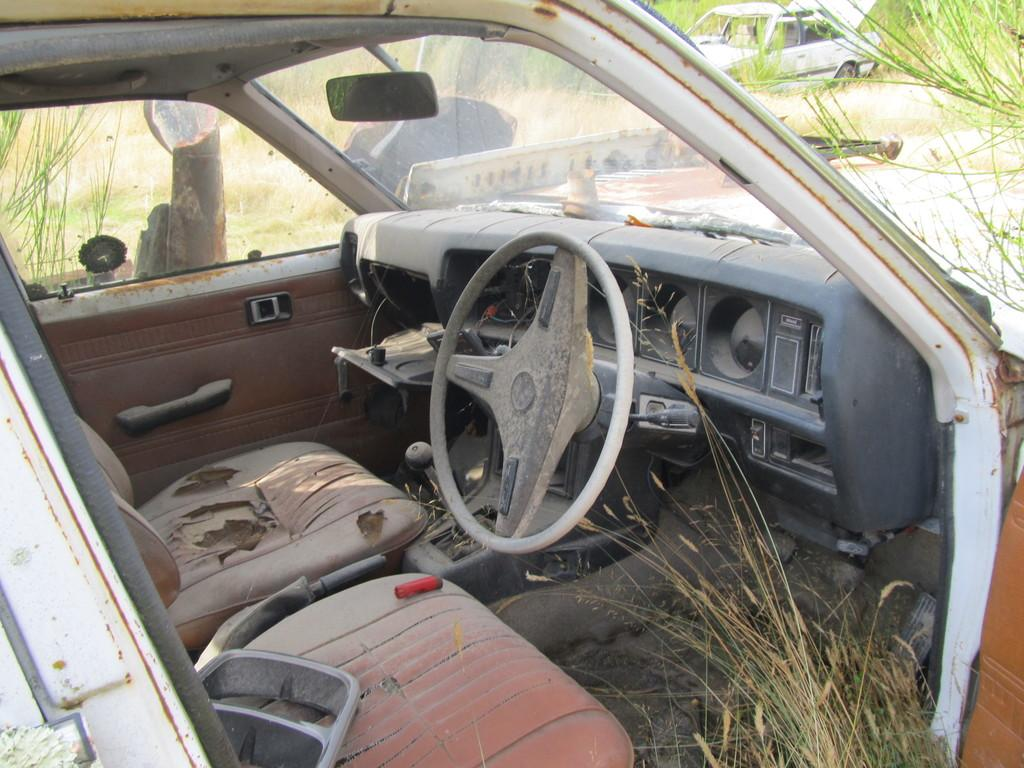What is the main subject of the image? There is a car in the image. What can be seen on the bottom right of the image? There is grass on the bottom right of the image. What is the color of the object on the car seat? There is a red object on the car seat. Can you describe the vehicle in the background of the image? There is a vehicle visible in the background of the image. Where is the faucet located in the image? There is no faucet present in the image. Is the person wearing a crown in the image? There are no people visible in the image, so it is impossible to determine if anyone is wearing a crown. 